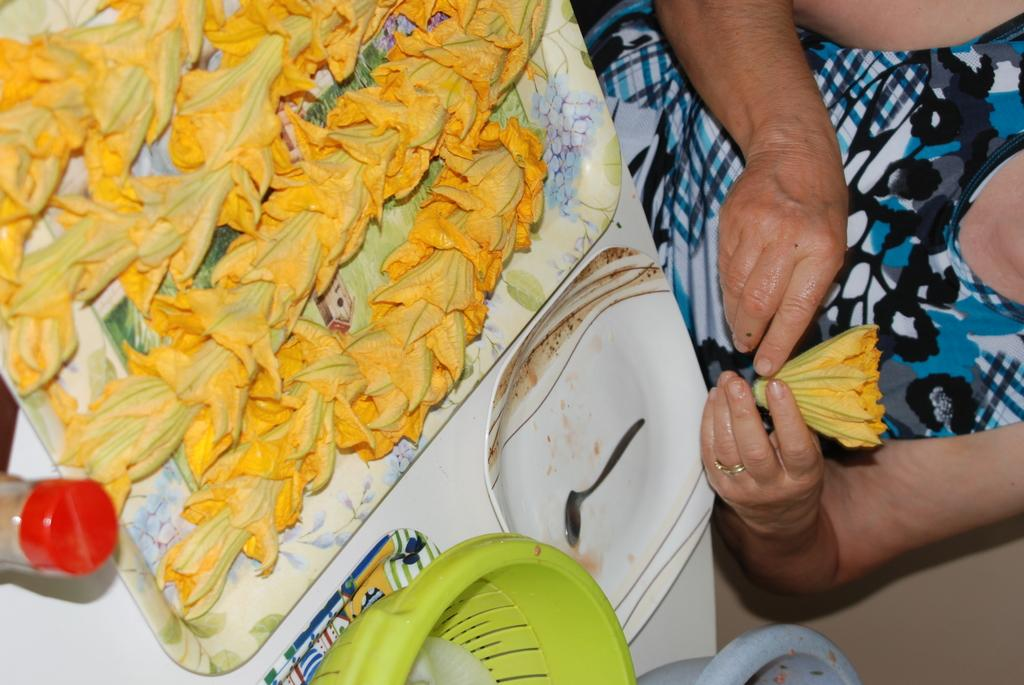What type of objects can be seen on the table in the image? There are flowers, trays, bowls, a spoon, and a jar on the table in the image. What is the person in the background doing? The person in the background is holding a flower. How many trays are visible in the image? There are trays in the image, but the exact number cannot be determined from the provided facts. What is the purpose of the spoon in the image? The spoon in the image is likely used for serving or eating, but its specific purpose cannot be determined from the provided facts. How does the person in the background transport the flower to their home? The image does not show the person transporting the flower or being at their home, so it cannot be determined from the image. 